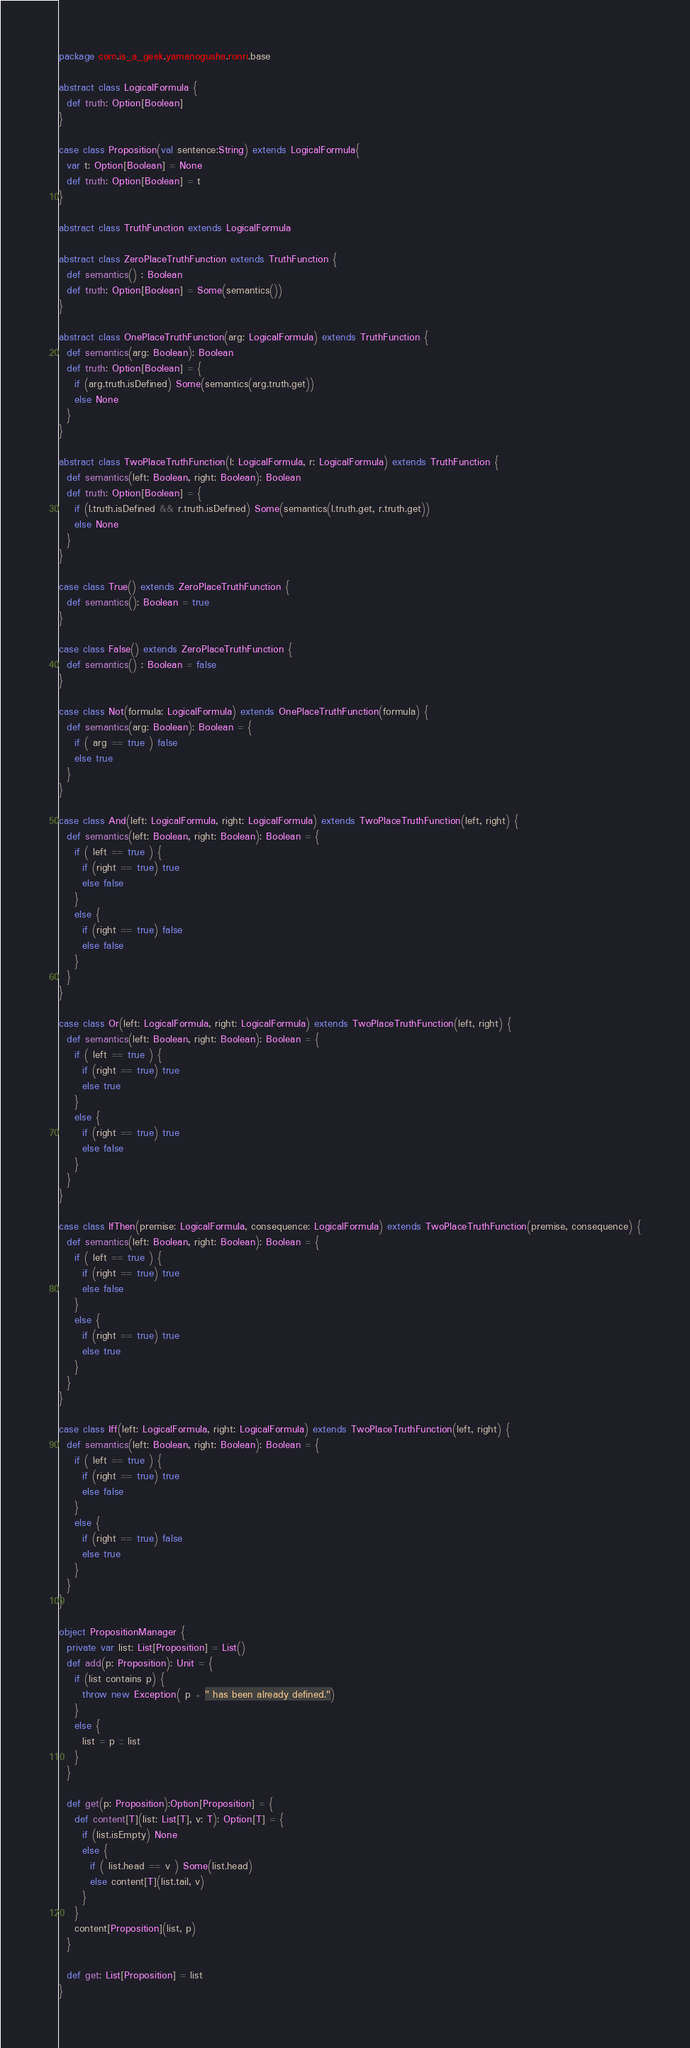Convert code to text. <code><loc_0><loc_0><loc_500><loc_500><_Scala_>package com.is_a_geek.yamanogusha.ronri.base

abstract class LogicalFormula {
  def truth: Option[Boolean]
}

case class Proposition(val sentence:String) extends LogicalFormula{
  var t: Option[Boolean] = None
  def truth: Option[Boolean] = t
}

abstract class TruthFunction extends LogicalFormula

abstract class ZeroPlaceTruthFunction extends TruthFunction {
  def semantics() : Boolean
  def truth: Option[Boolean] = Some(semantics())
}

abstract class OnePlaceTruthFunction(arg: LogicalFormula) extends TruthFunction {
  def semantics(arg: Boolean): Boolean
  def truth: Option[Boolean] = {
    if (arg.truth.isDefined) Some(semantics(arg.truth.get))
	else None
  }
}

abstract class TwoPlaceTruthFunction(l: LogicalFormula, r: LogicalFormula) extends TruthFunction {
  def semantics(left: Boolean, right: Boolean): Boolean
  def truth: Option[Boolean] = {
    if (l.truth.isDefined && r.truth.isDefined) Some(semantics(l.truth.get, r.truth.get))
	else None 
  }
}

case class True() extends ZeroPlaceTruthFunction {
  def semantics(): Boolean = true
}

case class False() extends ZeroPlaceTruthFunction {
  def semantics() : Boolean = false
}

case class Not(formula: LogicalFormula) extends OnePlaceTruthFunction(formula) {
  def semantics(arg: Boolean): Boolean = {
    if ( arg == true ) false
	else true
  }
}
    
case class And(left: LogicalFormula, right: LogicalFormula) extends TwoPlaceTruthFunction(left, right) {
  def semantics(left: Boolean, right: Boolean): Boolean = {
    if ( left == true ) {
	  if (right == true) true
	  else false
	}
	else {
	  if (right == true) false
	  else false
	}
  }
}

case class Or(left: LogicalFormula, right: LogicalFormula) extends TwoPlaceTruthFunction(left, right) {
  def semantics(left: Boolean, right: Boolean): Boolean = {
    if ( left == true ) {
	  if (right == true) true
	  else true
	}
	else {
	  if (right == true) true
	  else false
	}
  }
}

case class IfThen(premise: LogicalFormula, consequence: LogicalFormula) extends TwoPlaceTruthFunction(premise, consequence) {
  def semantics(left: Boolean, right: Boolean): Boolean = {
    if ( left == true ) {
	  if (right == true) true
	  else false
	}
	else {
	  if (right == true) true
	  else true
	}
  }
}

case class Iff(left: LogicalFormula, right: LogicalFormula) extends TwoPlaceTruthFunction(left, right) {
  def semantics(left: Boolean, right: Boolean): Boolean = {
    if ( left == true ) {
	  if (right == true) true
	  else false
	}
	else {
	  if (right == true) false
	  else true
	}
  }
}

object PropositionManager {
  private var list: List[Proposition] = List()
  def add(p: Proposition): Unit = {
    if (list contains p) {
	  throw new Exception( p + " has been already defined.")
	}
	else {
	  list = p :: list
	}
  }
  
  def get(p: Proposition):Option[Proposition] = {
    def content[T](list: List[T], v: T): Option[T] = {
	  if (list.isEmpty) None
	  else {
	    if ( list.head == v ) Some(list.head)
		else content[T](list.tail, v)
	  }
	}
	content[Proposition](list, p)
  }
  
  def get: List[Proposition] = list
}
</code> 